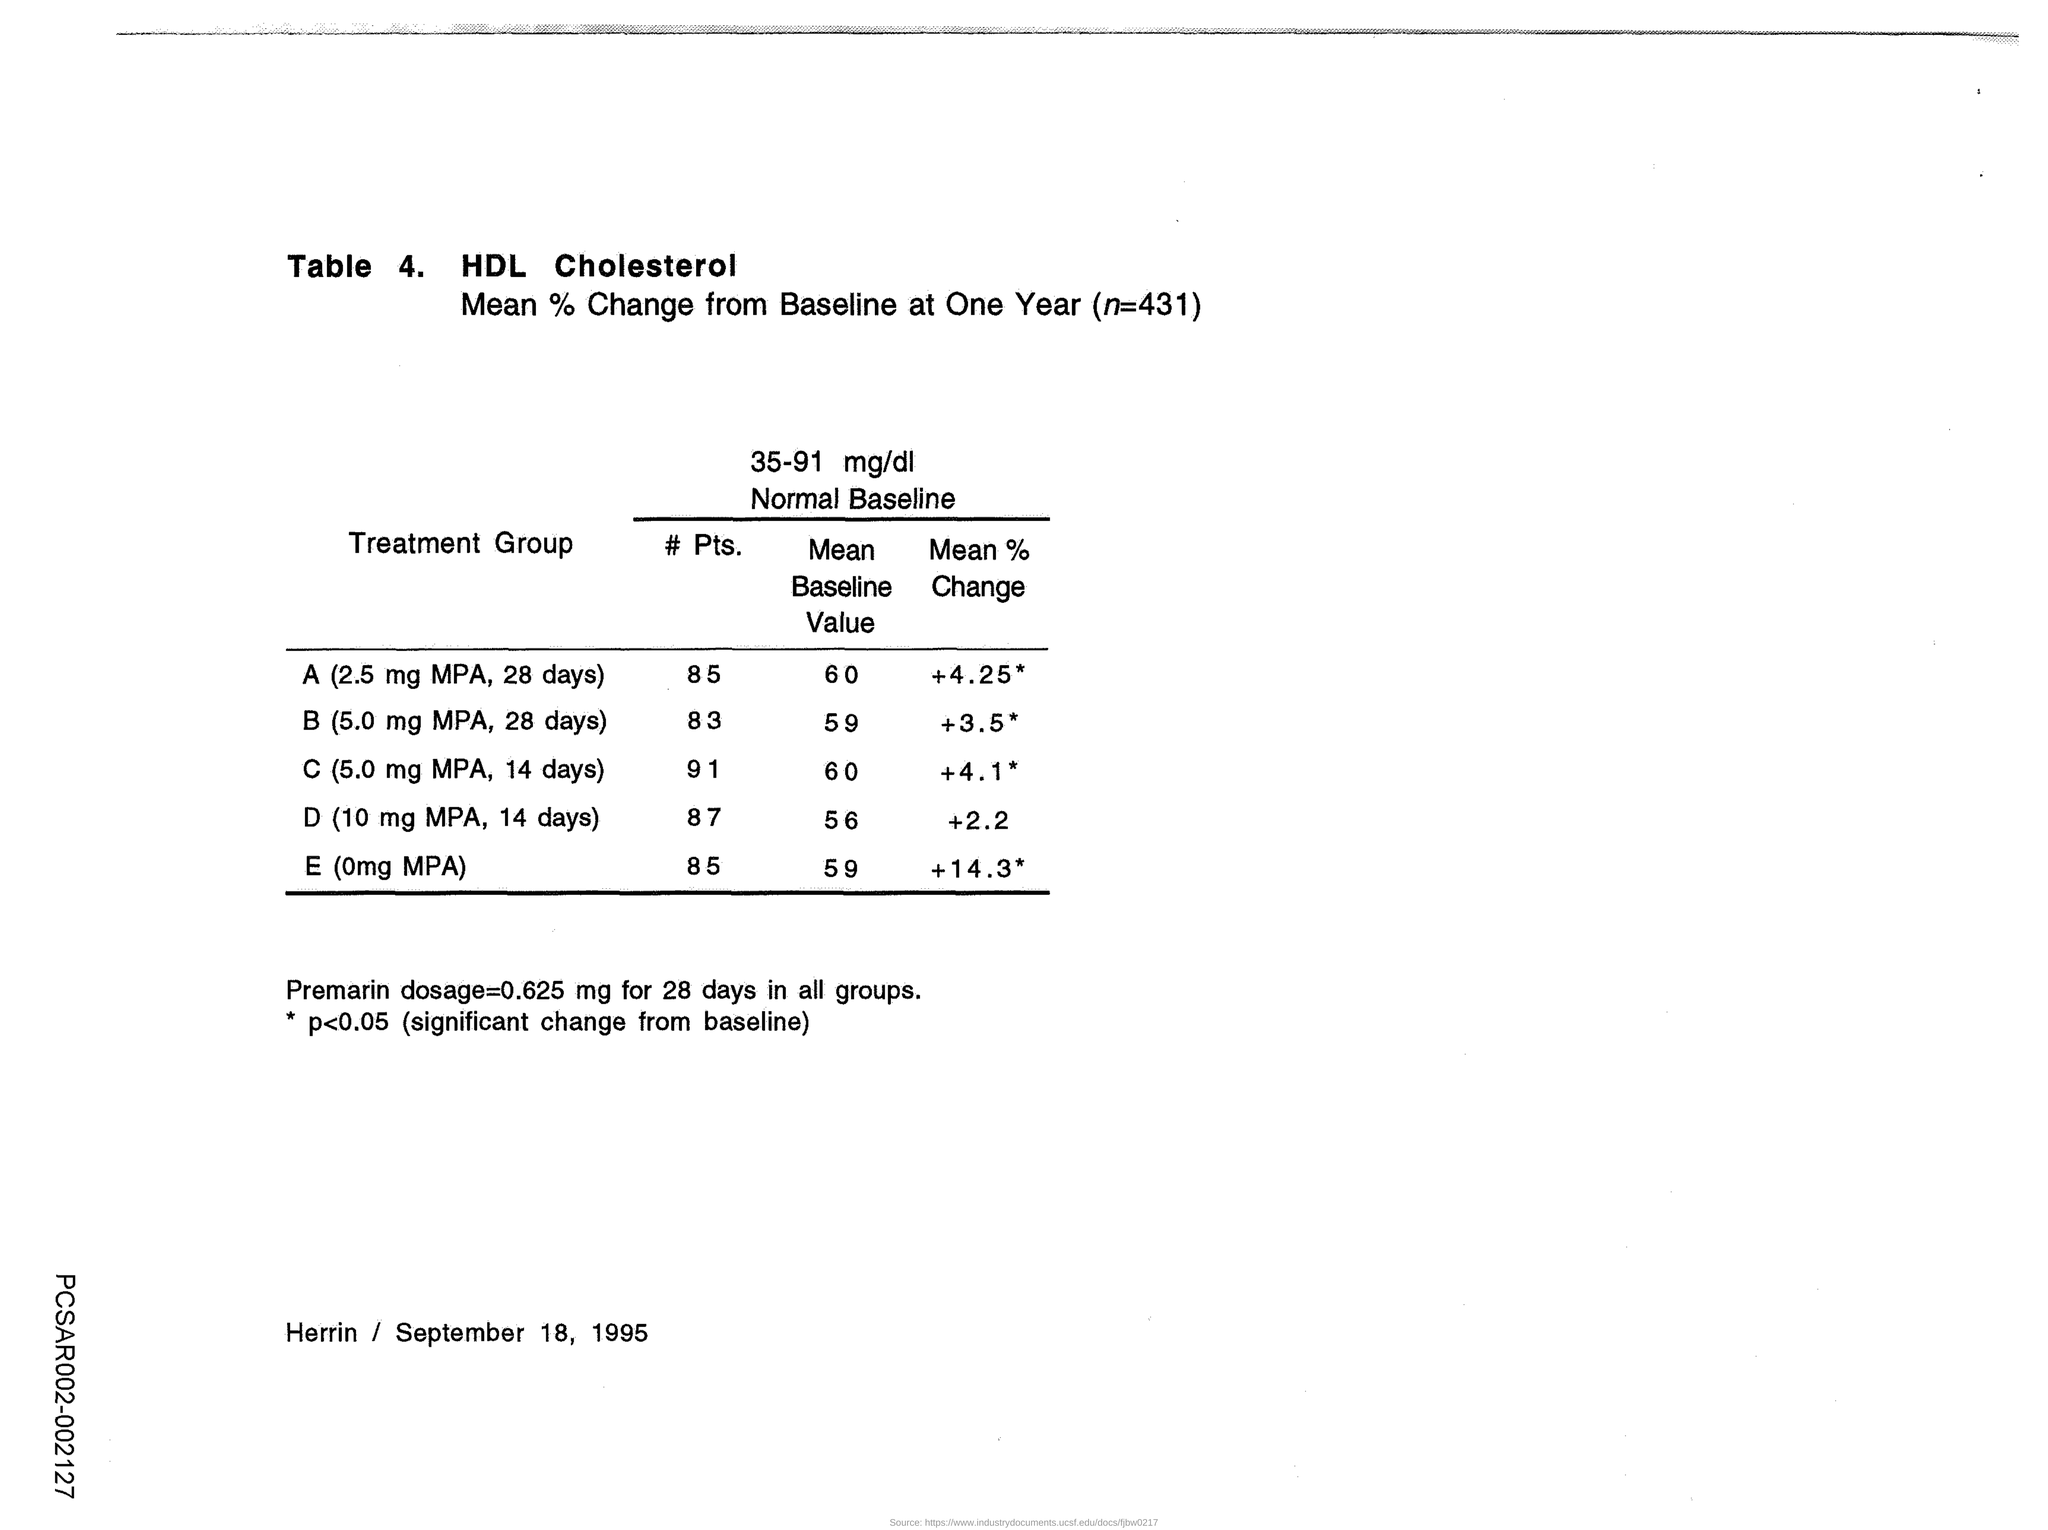Give some essential details in this illustration. The mean baseline value of the B (5.0 mg MPA, 28 days) treatment group was 59. The value of "n" at the top of the table is 431. The Premarin dosage for 28 days is 0.625 mg in all groups. The mean percentage change of the treatment group administered with 10 mg MPA for 14 days is +2.2%. The second treatment group mentioned in the table is B, which involves administering 5.0 mg of MPA daily for 28 days. 